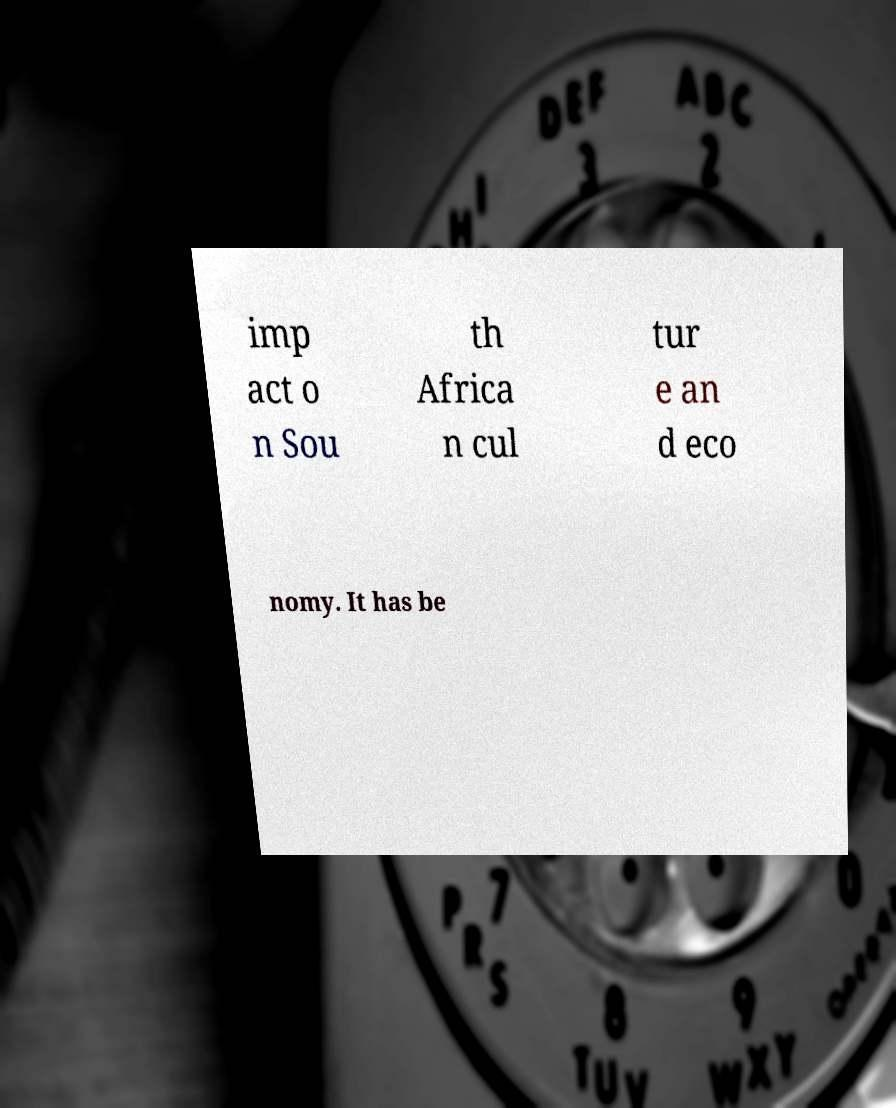There's text embedded in this image that I need extracted. Can you transcribe it verbatim? imp act o n Sou th Africa n cul tur e an d eco nomy. It has be 